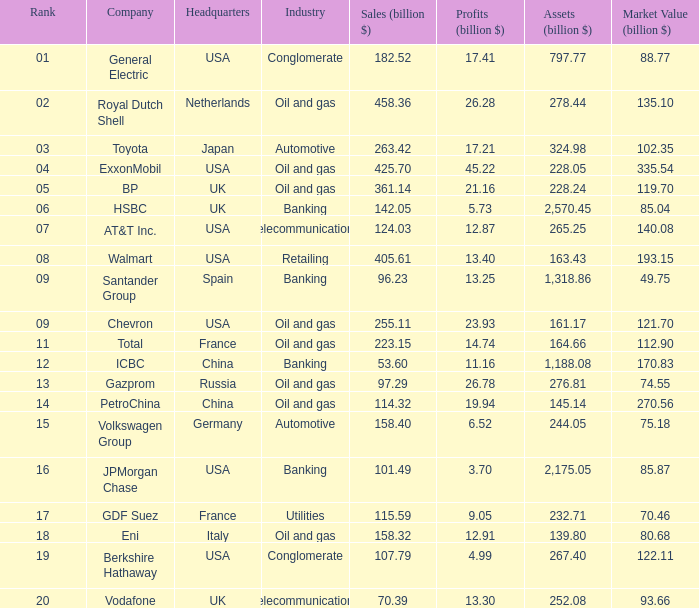What are the minimum profits (billion $) for a company with 42 None. 